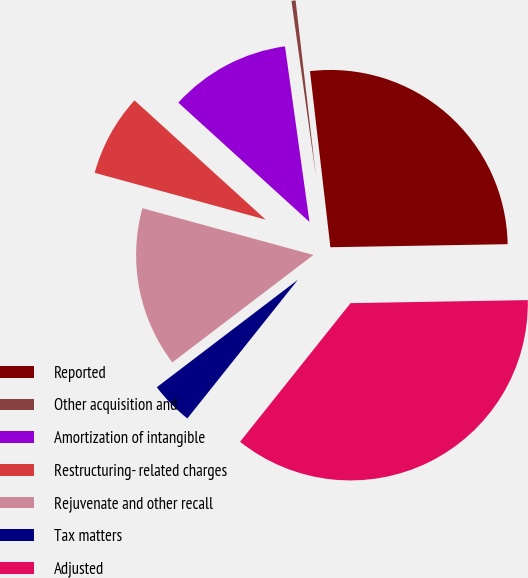<chart> <loc_0><loc_0><loc_500><loc_500><pie_chart><fcel>Reported<fcel>Other acquisition and<fcel>Amortization of intangible<fcel>Restructuring- related charges<fcel>Rejuvenate and other recall<fcel>Tax matters<fcel>Adjusted<nl><fcel>26.56%<fcel>0.37%<fcel>11.05%<fcel>7.49%<fcel>14.61%<fcel>3.93%<fcel>35.98%<nl></chart> 